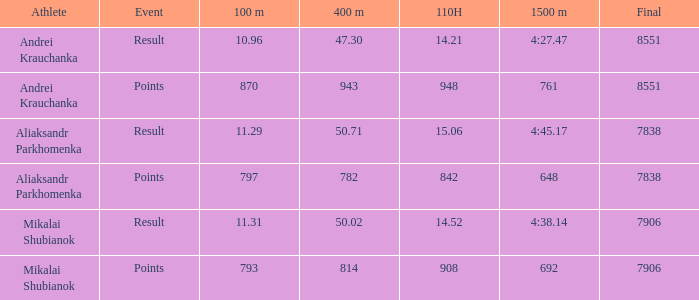What was the 100m that the 110H was less than 14.52 and the 400m was more than 47.3? None. 